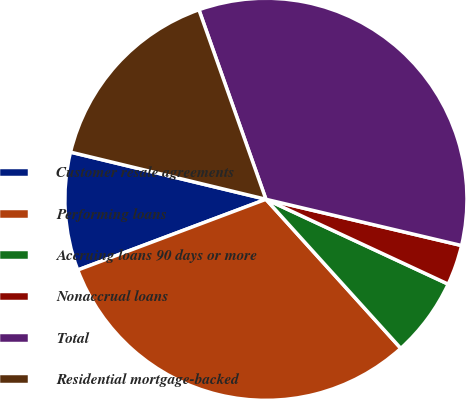Convert chart. <chart><loc_0><loc_0><loc_500><loc_500><pie_chart><fcel>Customer resale agreements<fcel>Performing loans<fcel>Accruing loans 90 days or more<fcel>Nonaccrual loans<fcel>Total<fcel>Residential mortgage-backed<nl><fcel>9.49%<fcel>30.98%<fcel>6.36%<fcel>3.24%<fcel>34.1%<fcel>15.82%<nl></chart> 